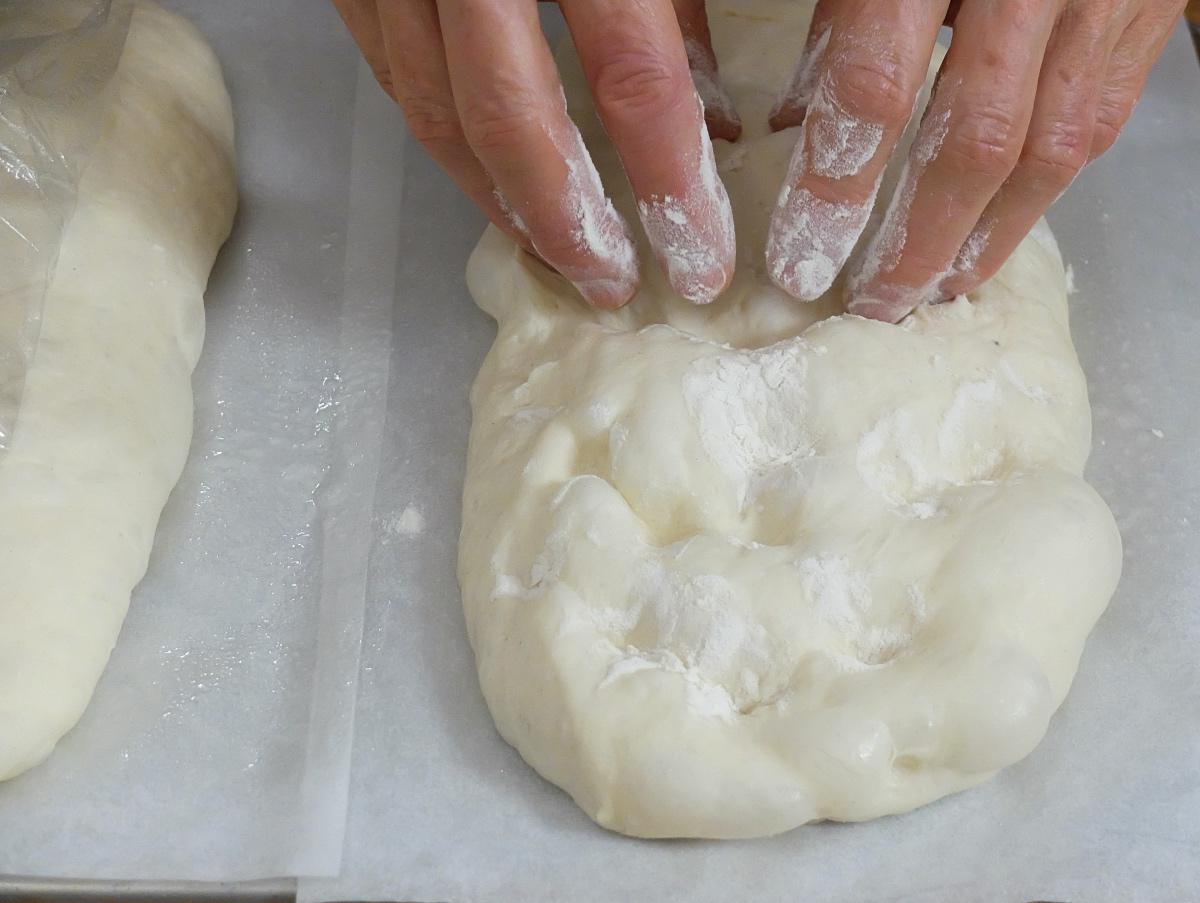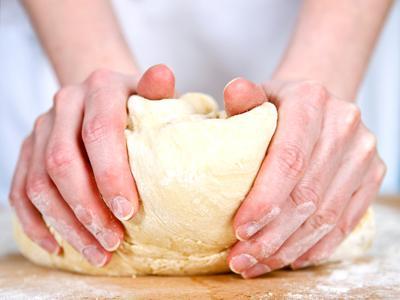The first image is the image on the left, the second image is the image on the right. Considering the images on both sides, is "There are three hands visible." valid? Answer yes or no. No. 